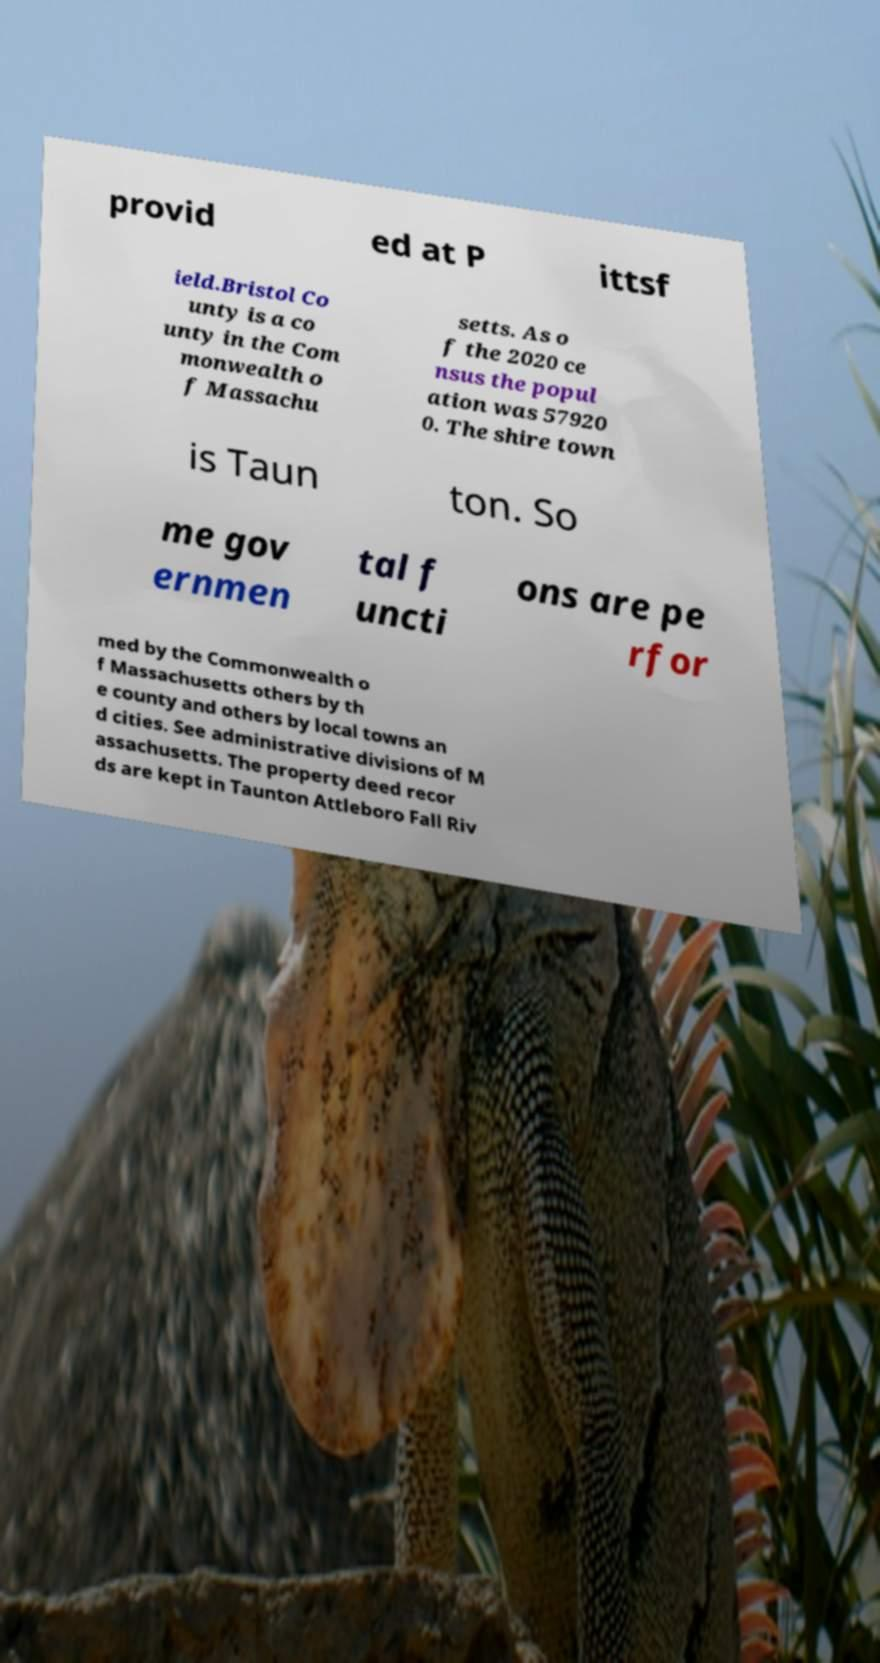Can you read and provide the text displayed in the image?This photo seems to have some interesting text. Can you extract and type it out for me? provid ed at P ittsf ield.Bristol Co unty is a co unty in the Com monwealth o f Massachu setts. As o f the 2020 ce nsus the popul ation was 57920 0. The shire town is Taun ton. So me gov ernmen tal f uncti ons are pe rfor med by the Commonwealth o f Massachusetts others by th e county and others by local towns an d cities. See administrative divisions of M assachusetts. The property deed recor ds are kept in Taunton Attleboro Fall Riv 